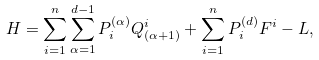Convert formula to latex. <formula><loc_0><loc_0><loc_500><loc_500>H = \sum _ { i = 1 } ^ { n } \sum ^ { d - 1 } _ { \alpha = 1 } P ^ { ( \alpha ) } _ { i } Q ^ { i } _ { ( \alpha + 1 ) } + \sum _ { i = 1 } ^ { n } P ^ { ( d ) } _ { i } F ^ { i } - L ,</formula> 